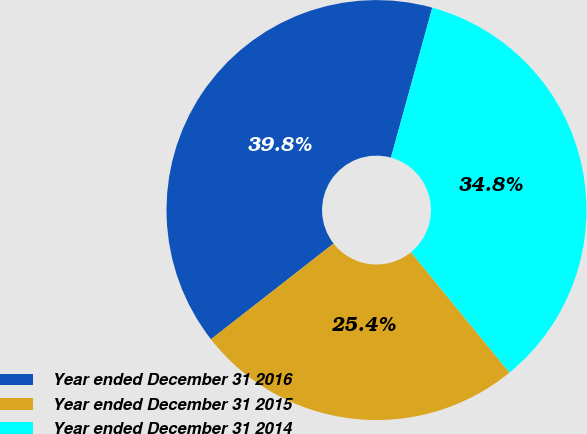<chart> <loc_0><loc_0><loc_500><loc_500><pie_chart><fcel>Year ended December 31 2016<fcel>Year ended December 31 2015<fcel>Year ended December 31 2014<nl><fcel>39.83%<fcel>25.37%<fcel>34.8%<nl></chart> 